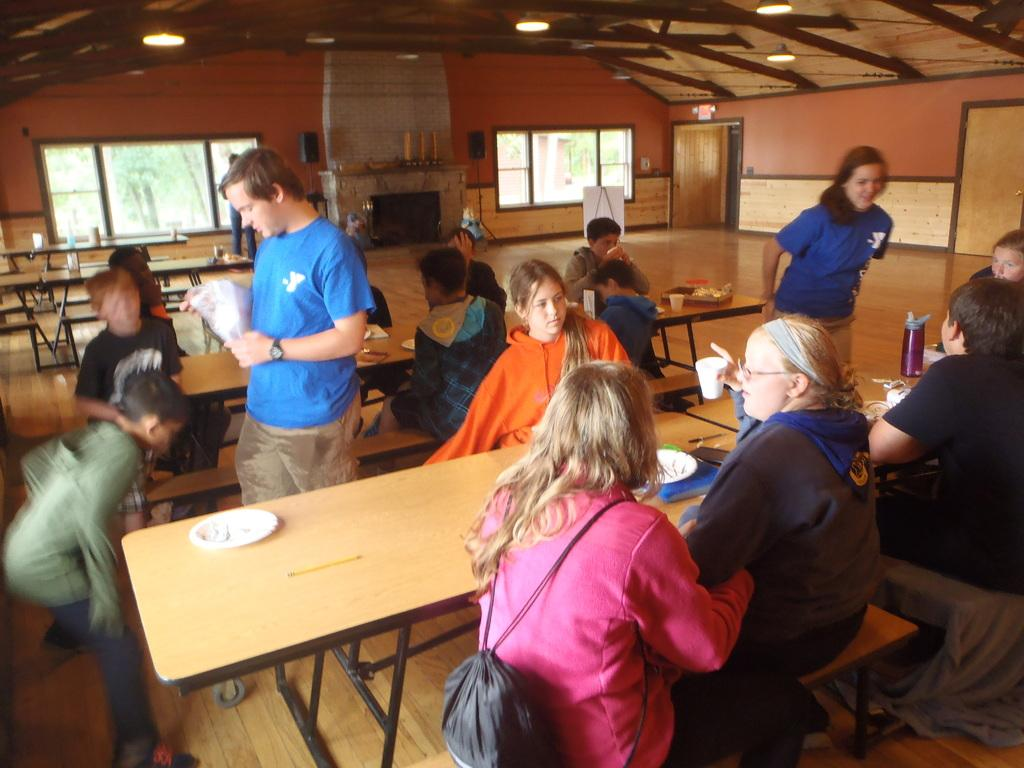Who or what is present in the image? There are people in the image. What type of furniture is visible in the image? There are chairs and a table in the image. What objects are on the table? There are plates and glasses on the table. What type of soup is being served in the image? There is no soup present in the image. What month is it in the image? The month cannot be determined from the image. 